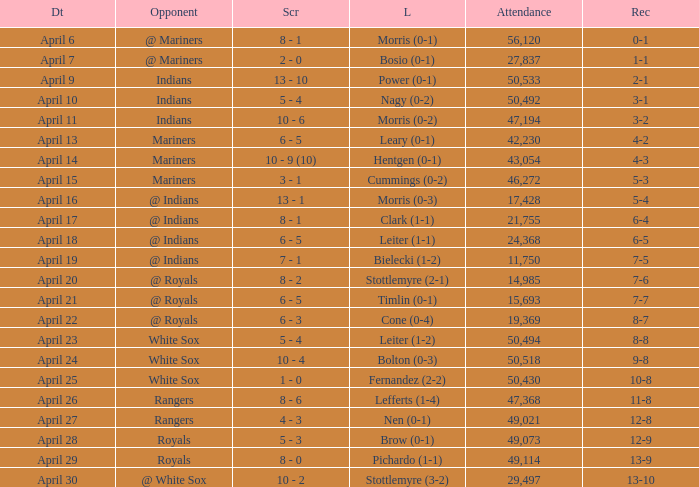What scored is recorded on April 24? 10 - 4. 